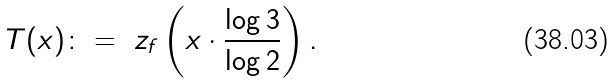Convert formula to latex. <formula><loc_0><loc_0><loc_500><loc_500>T ( x ) \colon = \ z _ { f } \left ( x \cdot \frac { \log 3 } { \log 2 } \right ) .</formula> 